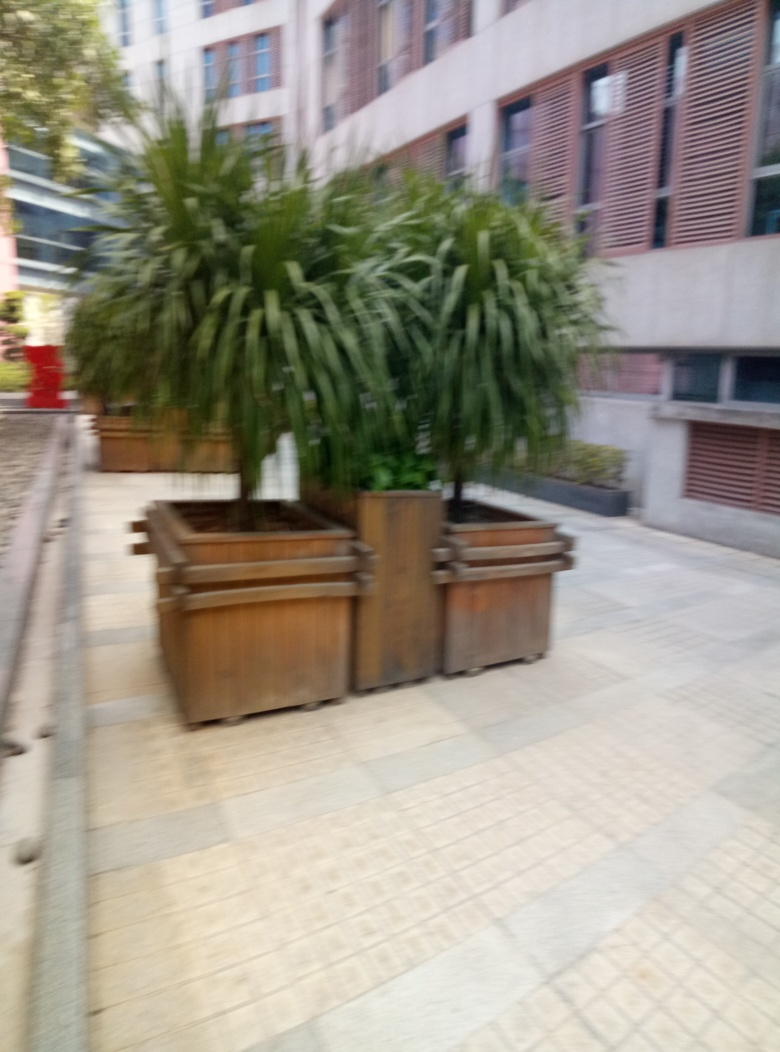What kind of location does this picture depict? The setting appears to be an outdoor area of an urban office building or institutional complex, as suggested by the tiled walkway, structured planters, and the architectural design of the facade in the background. 